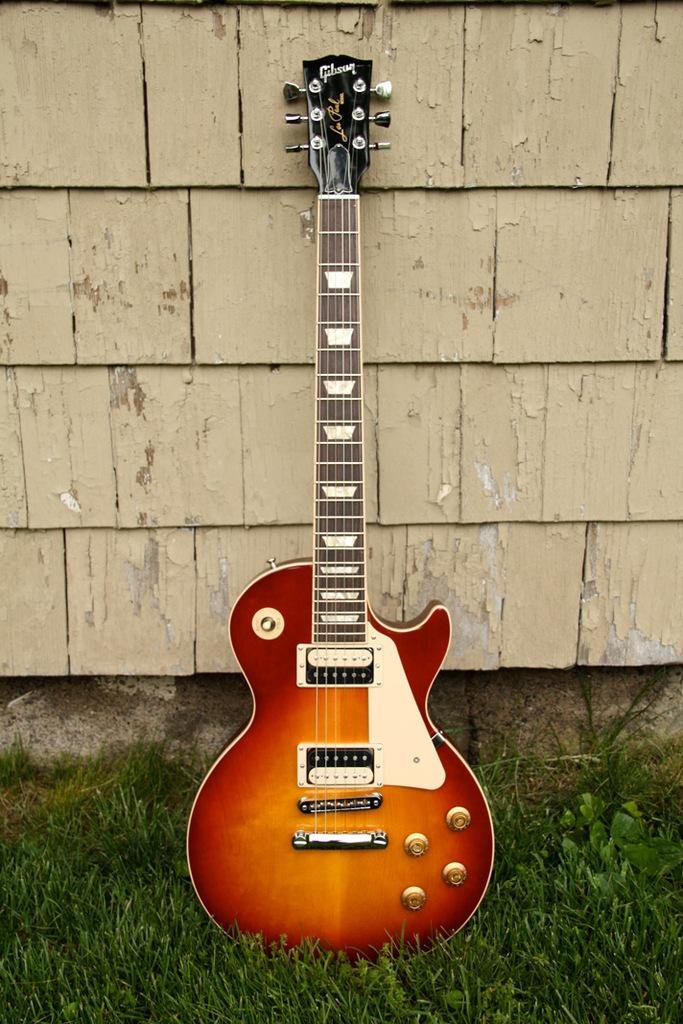What musical instrument is present in the image? There is a guitar in the image. What type of surface can be seen behind the guitar? There is a wall in the image. What type of natural environment is visible in the image? There is grass visible in the image. What type of yam is growing on the wall in the image? There is no yam present in the image; it features a guitar and a wall. What type of badge is visible on the guitar in the image? There is no badge visible on the guitar in the image. 